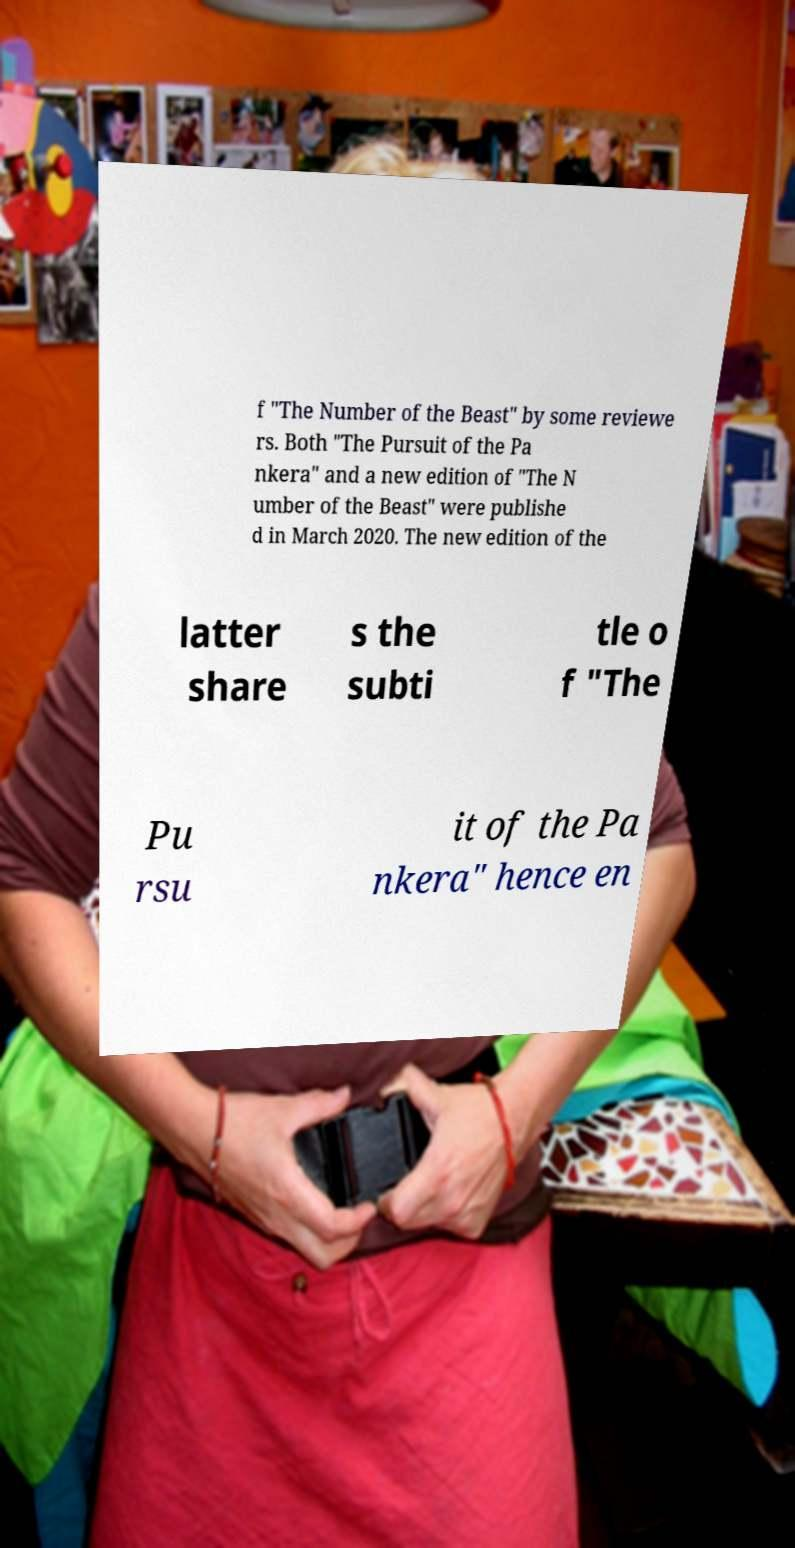Could you extract and type out the text from this image? f "The Number of the Beast" by some reviewe rs. Both "The Pursuit of the Pa nkera" and a new edition of "The N umber of the Beast" were publishe d in March 2020. The new edition of the latter share s the subti tle o f "The Pu rsu it of the Pa nkera" hence en 